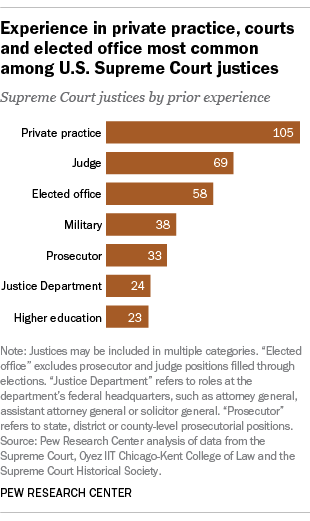Point out several critical features in this image. The speaker is suggesting to add the military and prosecutor experiences and subtract the result from the private practice experience, resulting in a total of 34. The largest bar value is 105. 